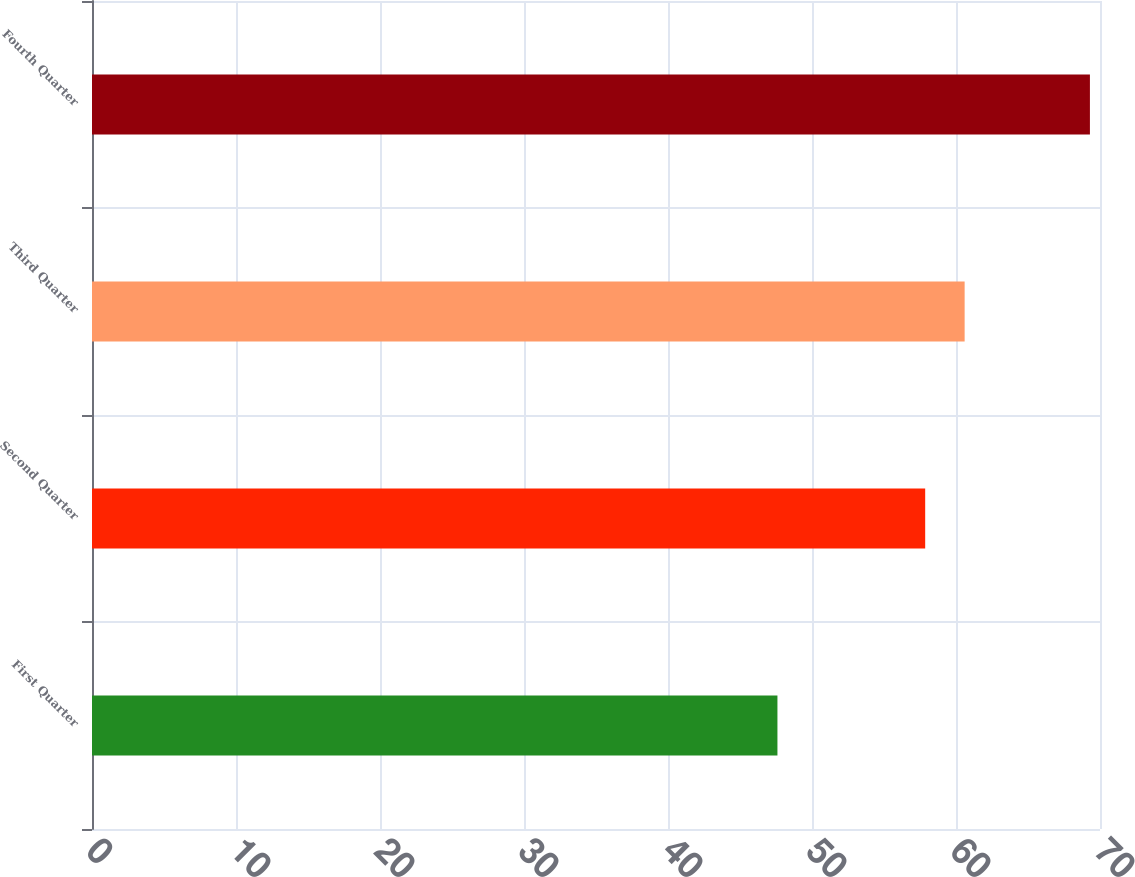Convert chart to OTSL. <chart><loc_0><loc_0><loc_500><loc_500><bar_chart><fcel>First Quarter<fcel>Second Quarter<fcel>Third Quarter<fcel>Fourth Quarter<nl><fcel>47.6<fcel>57.86<fcel>60.6<fcel>69.3<nl></chart> 